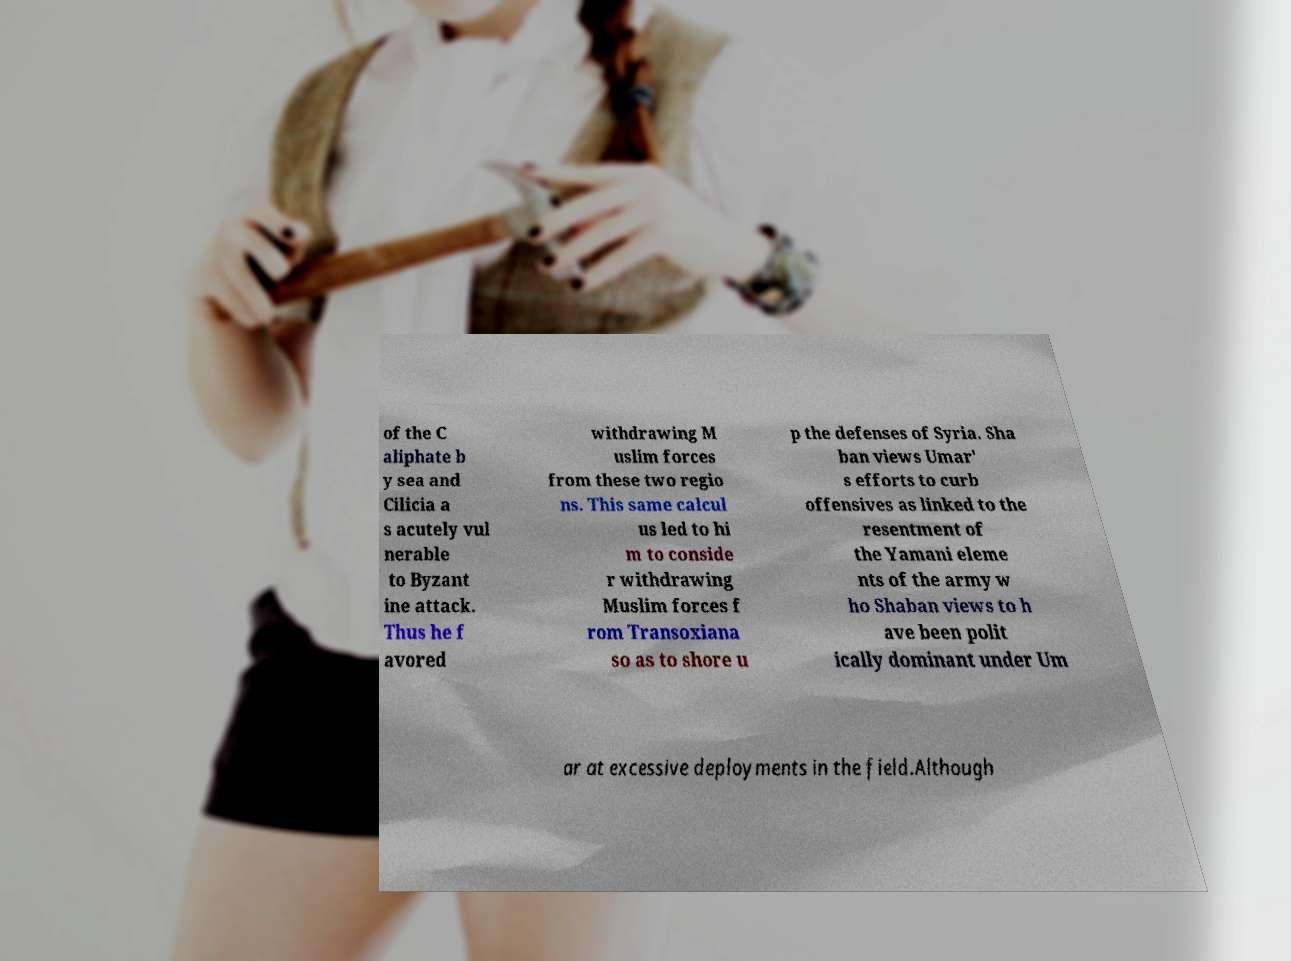Could you extract and type out the text from this image? of the C aliphate b y sea and Cilicia a s acutely vul nerable to Byzant ine attack. Thus he f avored withdrawing M uslim forces from these two regio ns. This same calcul us led to hi m to conside r withdrawing Muslim forces f rom Transoxiana so as to shore u p the defenses of Syria. Sha ban views Umar' s efforts to curb offensives as linked to the resentment of the Yamani eleme nts of the army w ho Shaban views to h ave been polit ically dominant under Um ar at excessive deployments in the field.Although 